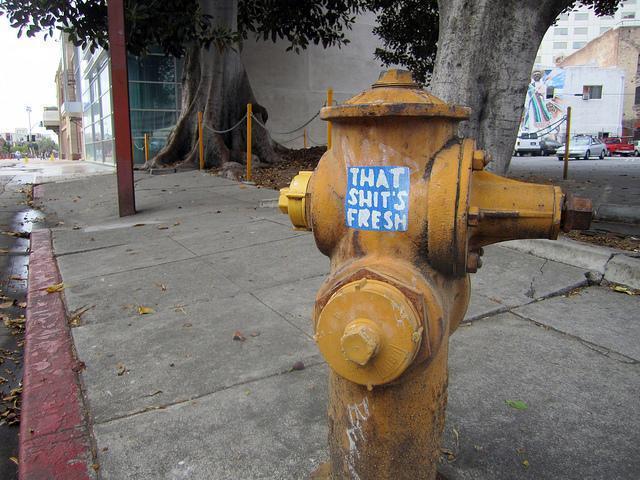How many trees are there?
Give a very brief answer. 2. 